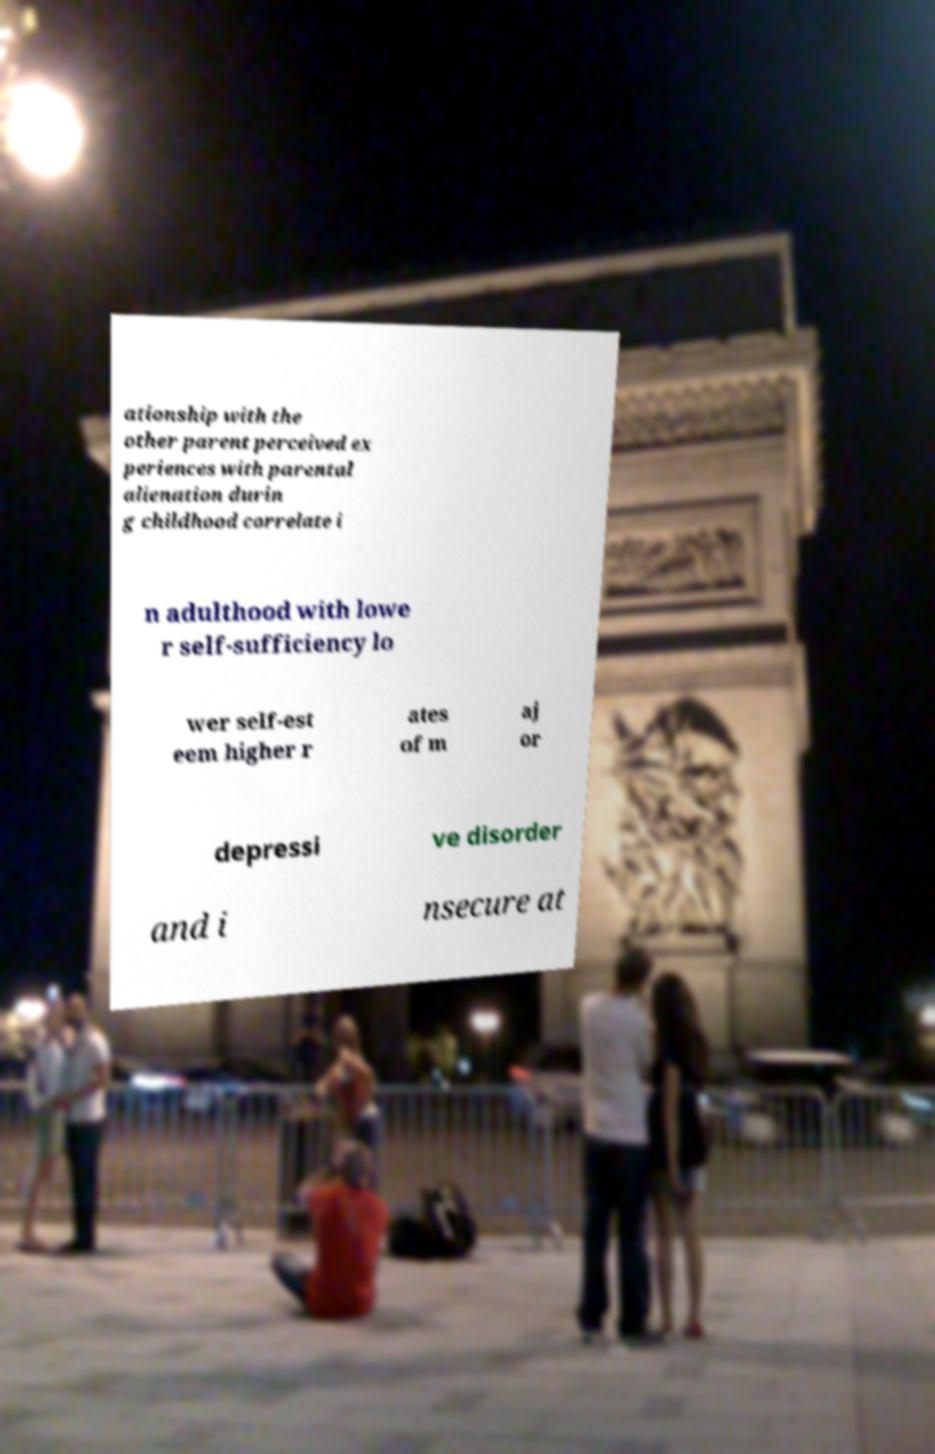There's text embedded in this image that I need extracted. Can you transcribe it verbatim? ationship with the other parent perceived ex periences with parental alienation durin g childhood correlate i n adulthood with lowe r self-sufficiency lo wer self-est eem higher r ates of m aj or depressi ve disorder and i nsecure at 